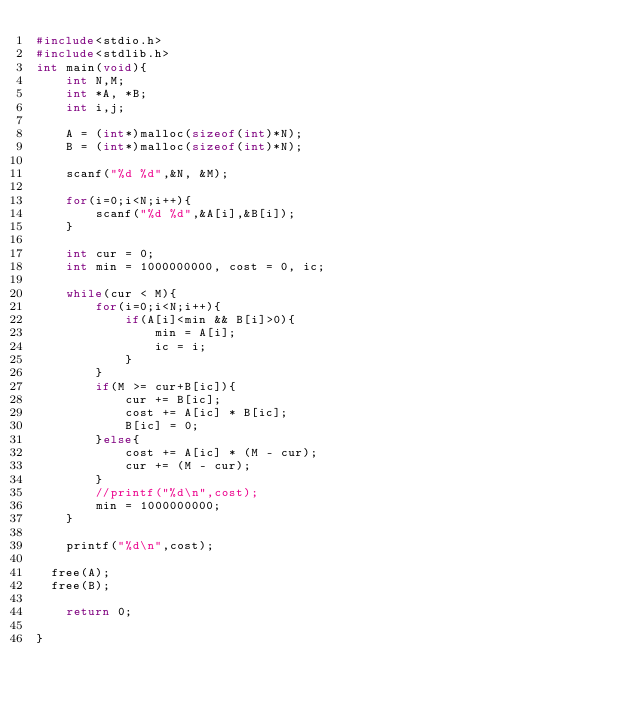<code> <loc_0><loc_0><loc_500><loc_500><_C_>#include<stdio.h>
#include<stdlib.h>
int main(void){
    int N,M;
    int *A, *B;
    int i,j;

    A = (int*)malloc(sizeof(int)*N);
    B = (int*)malloc(sizeof(int)*N);

    scanf("%d %d",&N, &M);

    for(i=0;i<N;i++){
        scanf("%d %d",&A[i],&B[i]);
    }

    int cur = 0;
    int min = 1000000000, cost = 0, ic;

    while(cur < M){
        for(i=0;i<N;i++){
            if(A[i]<min && B[i]>0){
                min = A[i];
                ic = i;
            }
        }
        if(M >= cur+B[ic]){
            cur += B[ic];
            cost += A[ic] * B[ic]; 
            B[ic] = 0;
        }else{
            cost += A[ic] * (M - cur);
            cur += (M - cur);
        }
        //printf("%d\n",cost);
        min = 1000000000;
    }

    printf("%d\n",cost);
  
  free(A);
  free(B);

    return 0;

}</code> 